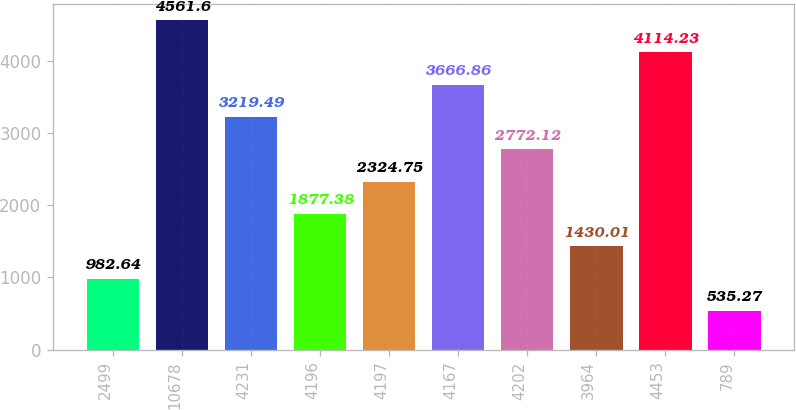<chart> <loc_0><loc_0><loc_500><loc_500><bar_chart><fcel>2499<fcel>10678<fcel>4231<fcel>4196<fcel>4197<fcel>4167<fcel>4202<fcel>3964<fcel>4453<fcel>789<nl><fcel>982.64<fcel>4561.6<fcel>3219.49<fcel>1877.38<fcel>2324.75<fcel>3666.86<fcel>2772.12<fcel>1430.01<fcel>4114.23<fcel>535.27<nl></chart> 